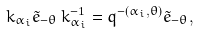<formula> <loc_0><loc_0><loc_500><loc_500>k _ { \alpha _ { i } } \tilde { e } _ { - \theta } \, k ^ { - 1 } _ { \alpha _ { i } } = q ^ { - ( \alpha _ { i } , \theta ) } \tilde { e } _ { - \theta } ,</formula> 